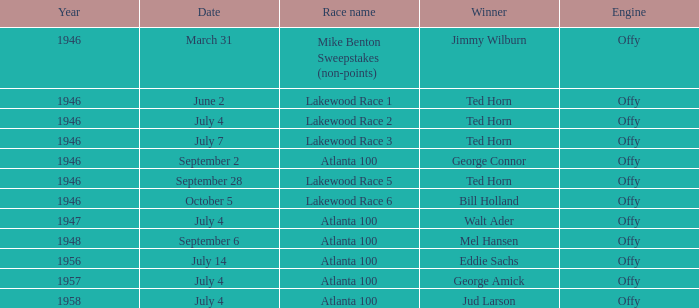What date did Ted Horn win Lakewood Race 2? July 4. 